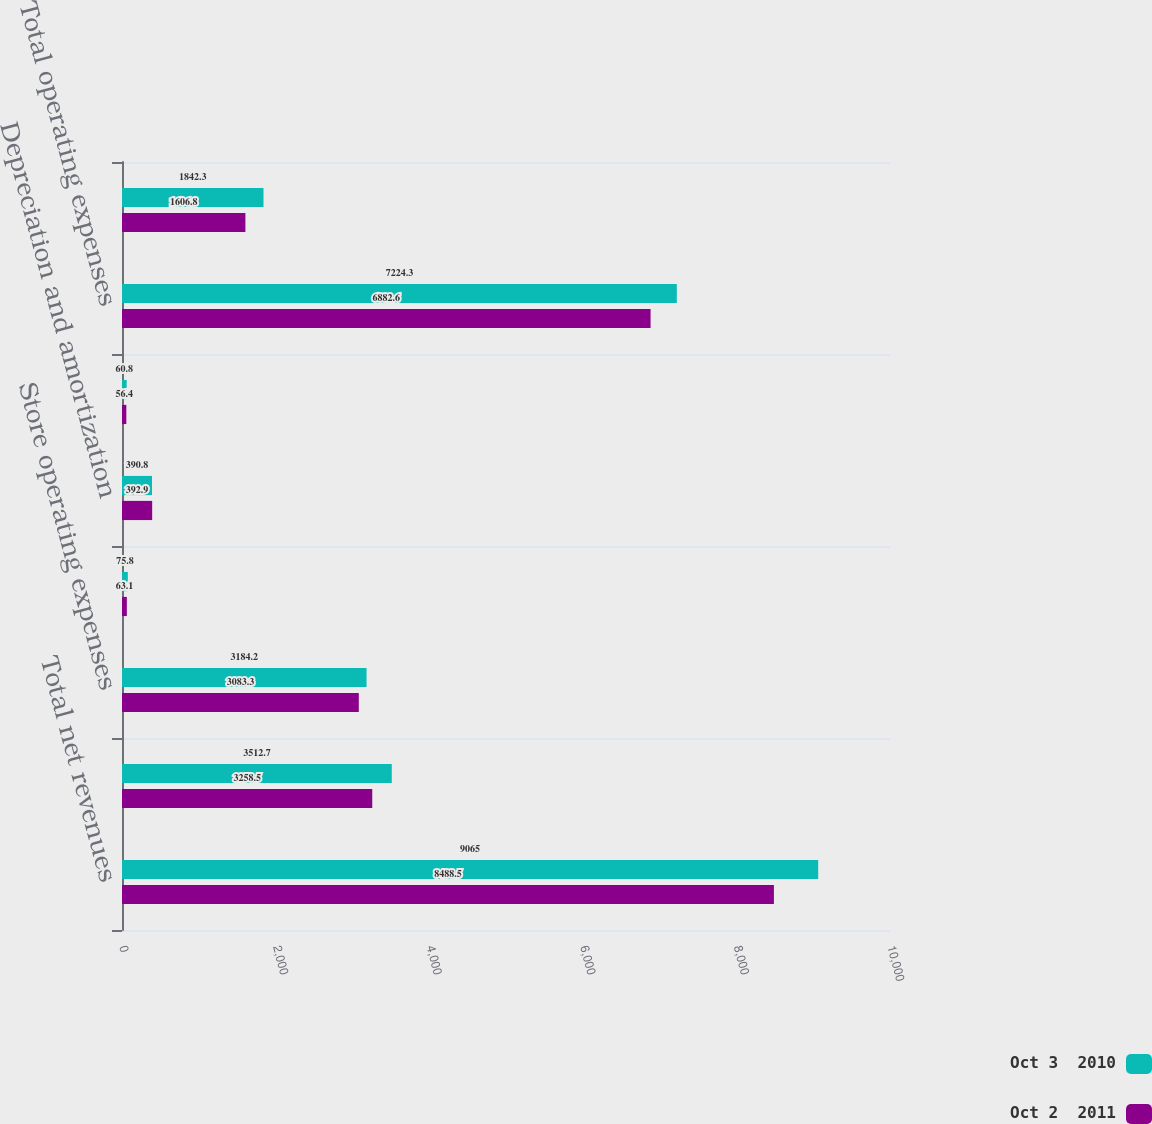<chart> <loc_0><loc_0><loc_500><loc_500><stacked_bar_chart><ecel><fcel>Total net revenues<fcel>Cost of sales including<fcel>Store operating expenses<fcel>Other operating expenses<fcel>Depreciation and amortization<fcel>General and administrative<fcel>Total operating expenses<fcel>Operating income<nl><fcel>Oct 3  2010<fcel>9065<fcel>3512.7<fcel>3184.2<fcel>75.8<fcel>390.8<fcel>60.8<fcel>7224.3<fcel>1842.3<nl><fcel>Oct 2  2011<fcel>8488.5<fcel>3258.5<fcel>3083.3<fcel>63.1<fcel>392.9<fcel>56.4<fcel>6882.6<fcel>1606.8<nl></chart> 